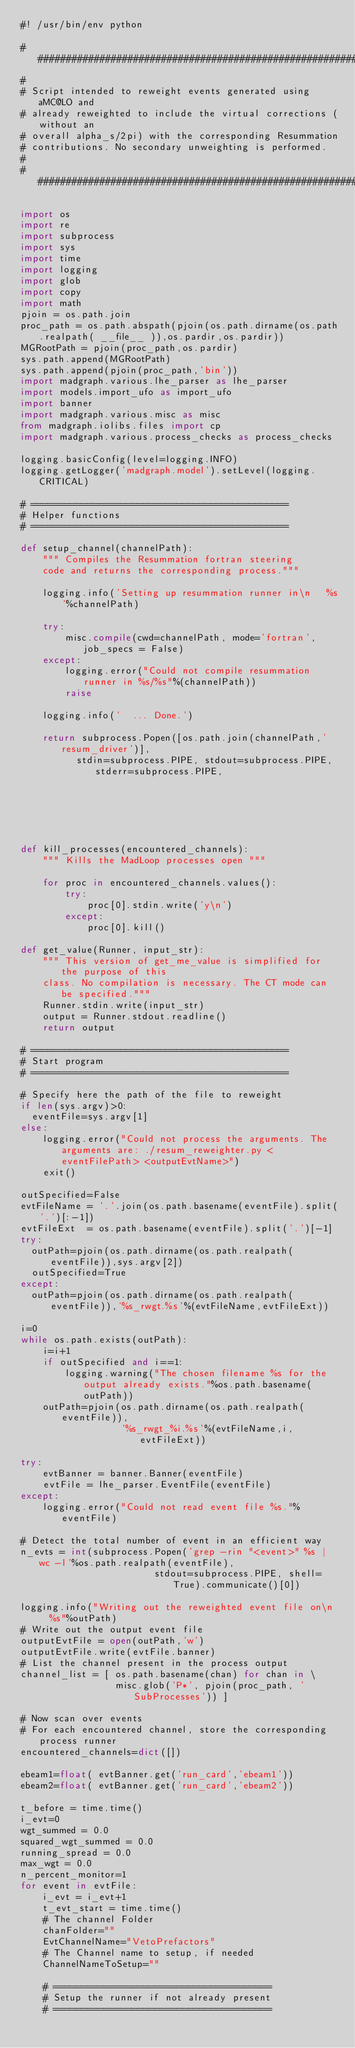Convert code to text. <code><loc_0><loc_0><loc_500><loc_500><_Python_>#! /usr/bin/env python

################################################################################
#
# Script intended to reweight events generated using aMC@LO and
# already reweighted to include the virtual corrections (without an
# overall alpha_s/2pi) with the corresponding Resummation
# contributions. No secondary unweighting is performed.
#
################################################################################

import os
import re
import subprocess
import sys
import time
import logging
import glob
import copy
import math
pjoin = os.path.join
proc_path = os.path.abspath(pjoin(os.path.dirname(os.path.realpath( __file__ )),os.pardir,os.pardir))
MGRootPath = pjoin(proc_path,os.pardir)
sys.path.append(MGRootPath)
sys.path.append(pjoin(proc_path,'bin'))
import madgraph.various.lhe_parser as lhe_parser
import models.import_ufo as import_ufo
import banner
import madgraph.various.misc as misc
from madgraph.iolibs.files import cp
import madgraph.various.process_checks as process_checks

logging.basicConfig(level=logging.INFO)
logging.getLogger('madgraph.model').setLevel(logging.CRITICAL)

# ==============================================
# Helper functions
# ==============================================

def setup_channel(channelPath):
    """ Compiles the Resummation fortran steering 
    code and returns the corresponding process."""

    logging.info('Setting up resummation runner in\n   %s'%channelPath)

    try:
        misc.compile(cwd=channelPath, mode='fortran', job_specs = False)
    except:
        logging.error("Could not compile resummation runner in %s/%s"%(channelPath))
        raise
    
    logging.info('  ... Done.')
    
    return subprocess.Popen([os.path.join(channelPath,'resum_driver')], 
          stdin=subprocess.PIPE, stdout=subprocess.PIPE, stderr=subprocess.PIPE, 
                                                                   cwd=channelPath)

def kill_processes(encountered_channels):
    """ Kills the MadLoop processes open """

    for proc in encountered_channels.values():
        try:
            proc[0].stdin.write('y\n')
        except:
            proc[0].kill()

def get_value(Runner, input_str):
    """ This version of get_me_value is simplified for the purpose of this
    class. No compilation is necessary. The CT mode can be specified."""
    Runner.stdin.write(input_str)
    output = Runner.stdout.readline()  
    return output

# ==============================================
# Start program
# ==============================================

# Specify here the path of the file to reweight
if len(sys.argv)>0:
  eventFile=sys.argv[1]
else:
    logging.error("Could not process the arguments. The arguments are: ./resum_reweighter.py <eventFilePath> <outputEvtName>")
    exit()

outSpecified=False
evtFileName = '.'.join(os.path.basename(eventFile).split('.')[:-1])
evtFileExt  = os.path.basename(eventFile).split('.')[-1]
try:
  outPath=pjoin(os.path.dirname(os.path.realpath(eventFile)),sys.argv[2])
  outSpecified=True
except:
  outPath=pjoin(os.path.dirname(os.path.realpath(eventFile)),'%s_rwgt.%s'%(evtFileName,evtFileExt))

i=0
while os.path.exists(outPath):
    i=i+1    
    if outSpecified and i==1:
        logging.warning("The chosen filename %s for the output already exists."%os.path.basename(outPath))
    outPath=pjoin(os.path.dirname(os.path.realpath(eventFile)),
                  '%s_rwgt_%i.%s'%(evtFileName,i,evtFileExt))

try:
    evtBanner = banner.Banner(eventFile)    
    evtFile = lhe_parser.EventFile(eventFile)
except:
    logging.error("Could not read event file %s."%eventFile)

# Detect the total number of event in an efficient way
n_evts = int(subprocess.Popen('grep -rin "<event>" %s | wc -l'%os.path.realpath(eventFile),
                        stdout=subprocess.PIPE, shell=True).communicate()[0])

logging.info("Writing out the reweighted event file on\n   %s"%outPath)
# Write out the output event file
outputEvtFile = open(outPath,'w')
outputEvtFile.write(evtFile.banner)
# List the channel present in the process output
channel_list = [ os.path.basename(chan) for chan in \
                 misc.glob('P*', pjoin(proc_path, 'SubProcesses')) ]

# Now scan over events
# For each encountered channel, store the corresponding process runner
encountered_channels=dict([])

ebeam1=float( evtBanner.get('run_card','ebeam1'))
ebeam2=float( evtBanner.get('run_card','ebeam2'))

t_before = time.time()
i_evt=0
wgt_summed = 0.0
squared_wgt_summed = 0.0
running_spread = 0.0
max_wgt = 0.0
n_percent_monitor=1
for event in evtFile:
    i_evt = i_evt+1
    t_evt_start = time.time()    
    # The channel Folder
    chanFolder=""
    EvtChannelName="VetoPrefactors"
    # The Channel name to setup, if needed
    ChannelNameToSetup=""

    # =======================================
    # Setup the runner if not already present
    # =======================================
</code> 